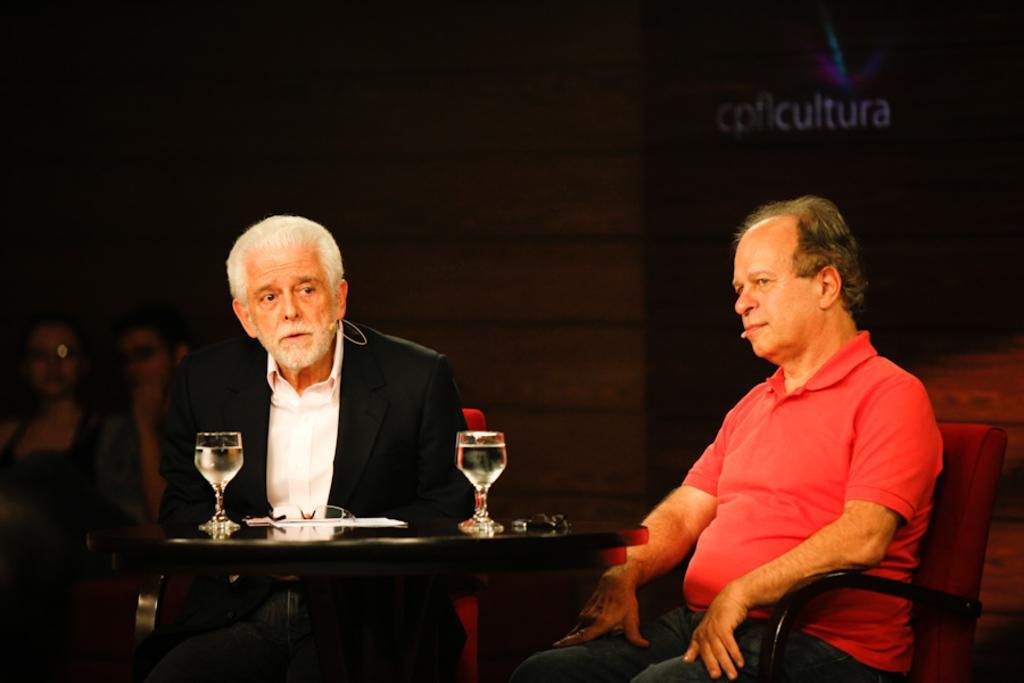Describe this image in one or two sentences. In this image i can see two men sitting on a chair, there are two glasses on the table,at the back ground there are two persons sitting and there is a wall. 